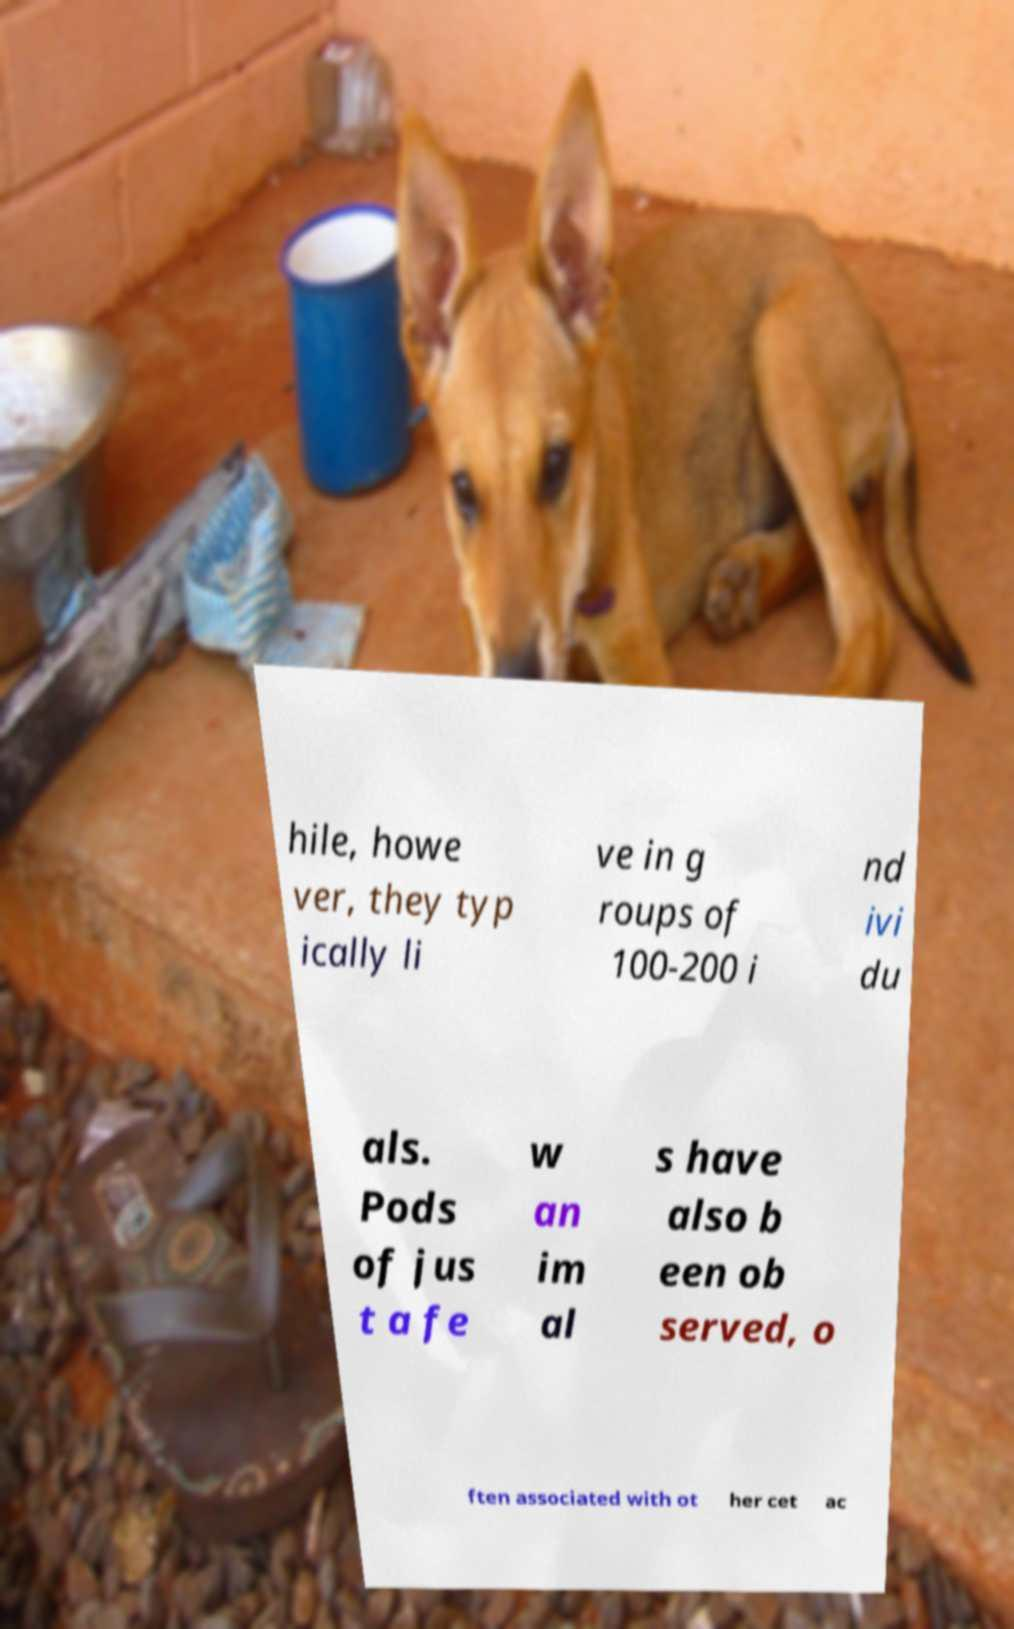There's text embedded in this image that I need extracted. Can you transcribe it verbatim? hile, howe ver, they typ ically li ve in g roups of 100-200 i nd ivi du als. Pods of jus t a fe w an im al s have also b een ob served, o ften associated with ot her cet ac 